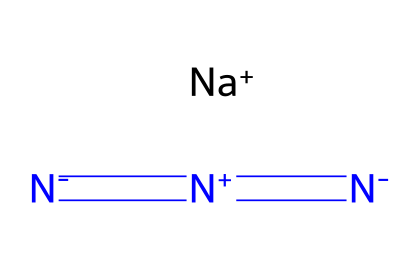What is the chemical name of this compound? The chemical structure represents sodium azide. Sodium (Na) is indicated by the Na+ ion, and the azide part is characterized by the series of nitrogen atoms (N) linked together through double bonds and negative charges.
Answer: sodium azide How many nitrogen atoms are present in sodium azide? The SMILES representation shows a total of three nitrogen atoms, which can be counted in the sequence [N-]=[N+]=[N-]. Each notation corresponds to one nitrogen atom.
Answer: three What charge does the sodium ion carry in this structure? In the chemical structure, sodium is represented as Na+, indicating that it carries a positive charge. The "+" sign denotes the cationic state of sodium in this compound.
Answer: positive What type of bond is formed between the nitrogen atoms in sodium azide? The nitrogen atoms are connected by a series of double bonds, as represented by the "=" signs in the SMILES notation. This indicates that the nitrogen atoms share two pairs of electrons, constituting a double bond.
Answer: double bond How is sodium azide typically utilized in luxury vehicles? Sodium azide is primarily used as a propellant in airbag systems due to its rapid decomposition into nitrogen gas when triggered, providing quick inflation for safety mechanisms in vehicles.
Answer: airbag systems What is the overall molecular charge of sodium azide? When considering the charges in the structure, the sodium ion has a +1 charge and the azide group (N3) has a -1 charge overall, leading to a neutral molecular charge when combined.
Answer: neutral What characteristic of sodium azide makes it effective in airbag deployment? The rapid decomposition of sodium azide into nitrogen gas during heating provides a large volume gas very quickly, which is necessary for rapid airbag inflation in emergencies.
Answer: rapid gas generation 